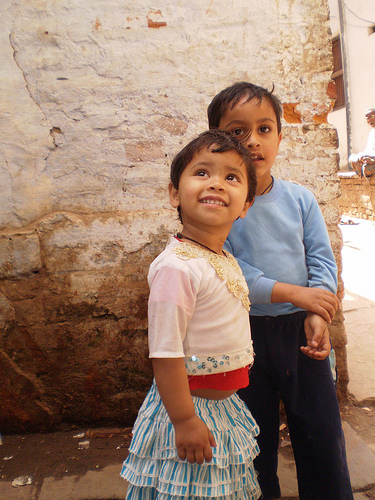<image>
Can you confirm if the girl is on the boy? No. The girl is not positioned on the boy. They may be near each other, but the girl is not supported by or resting on top of the boy. 